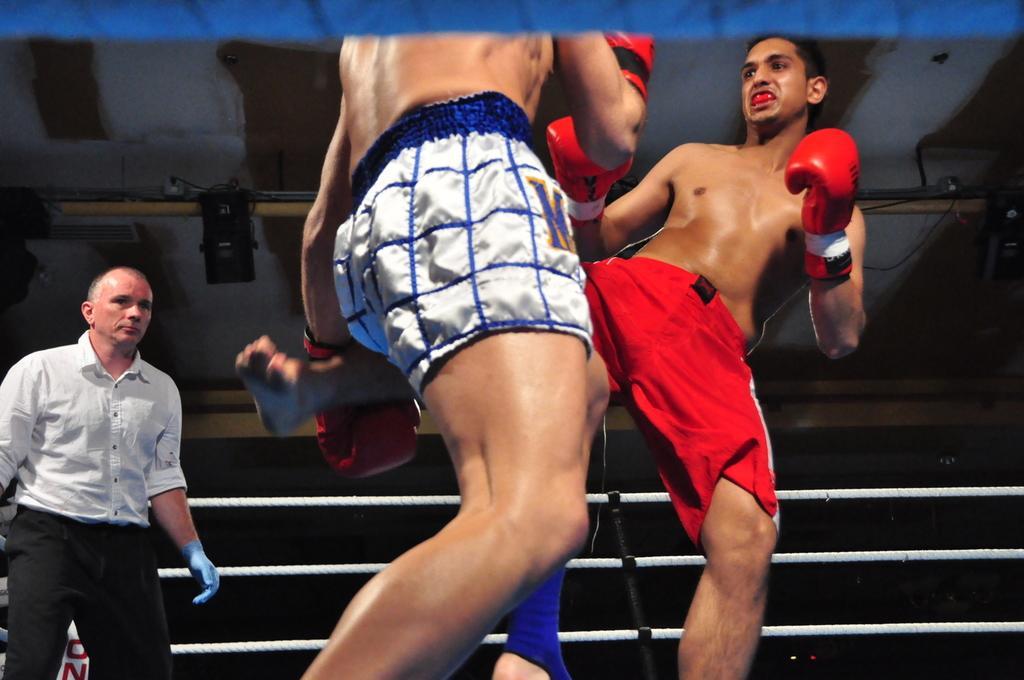In one or two sentences, can you explain what this image depicts? This image consists of two persons boxing. They are wearing shorts and gloves. On the left, there is a man wearing white shirt is standing in the ring. In the background, we can see the fencing of the ring. At the top, there is a roof to which speakers and lights are fixed. 